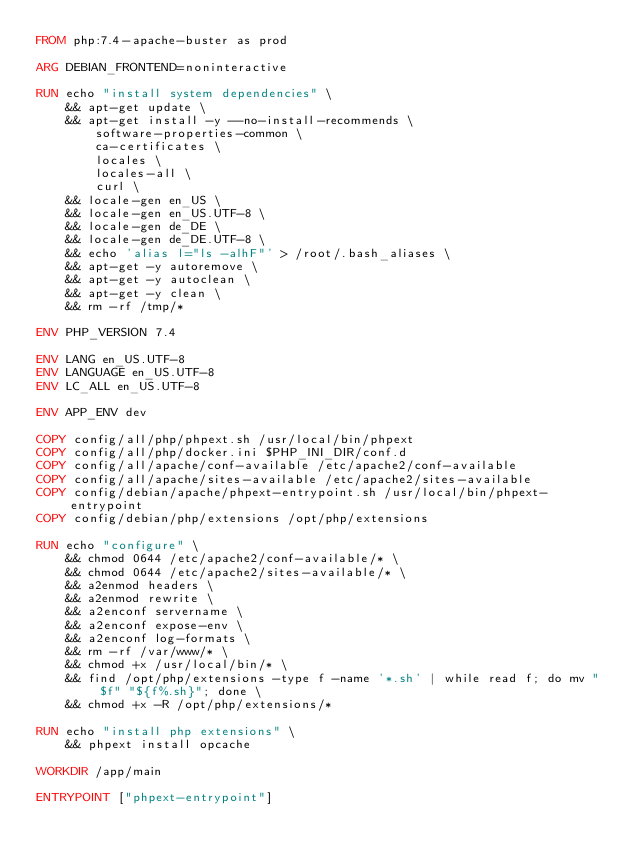Convert code to text. <code><loc_0><loc_0><loc_500><loc_500><_Dockerfile_>FROM php:7.4-apache-buster as prod

ARG DEBIAN_FRONTEND=noninteractive

RUN echo "install system dependencies" \
    && apt-get update \
    && apt-get install -y --no-install-recommends \
        software-properties-common \
        ca-certificates \
        locales \
        locales-all \
        curl \
    && locale-gen en_US \
    && locale-gen en_US.UTF-8 \
    && locale-gen de_DE \
    && locale-gen de_DE.UTF-8 \
    && echo 'alias l="ls -alhF"' > /root/.bash_aliases \
    && apt-get -y autoremove \
    && apt-get -y autoclean \
    && apt-get -y clean \
    && rm -rf /tmp/*

ENV PHP_VERSION 7.4

ENV LANG en_US.UTF-8
ENV LANGUAGE en_US.UTF-8
ENV LC_ALL en_US.UTF-8

ENV APP_ENV dev

COPY config/all/php/phpext.sh /usr/local/bin/phpext
COPY config/all/php/docker.ini $PHP_INI_DIR/conf.d
COPY config/all/apache/conf-available /etc/apache2/conf-available
COPY config/all/apache/sites-available /etc/apache2/sites-available
COPY config/debian/apache/phpext-entrypoint.sh /usr/local/bin/phpext-entrypoint
COPY config/debian/php/extensions /opt/php/extensions

RUN echo "configure" \
    && chmod 0644 /etc/apache2/conf-available/* \
    && chmod 0644 /etc/apache2/sites-available/* \
    && a2enmod headers \
    && a2enmod rewrite \
    && a2enconf servername \
    && a2enconf expose-env \
    && a2enconf log-formats \
    && rm -rf /var/www/* \
    && chmod +x /usr/local/bin/* \
    && find /opt/php/extensions -type f -name '*.sh' | while read f; do mv "$f" "${f%.sh}"; done \
    && chmod +x -R /opt/php/extensions/*

RUN echo "install php extensions" \
    && phpext install opcache

WORKDIR /app/main

ENTRYPOINT ["phpext-entrypoint"]
</code> 